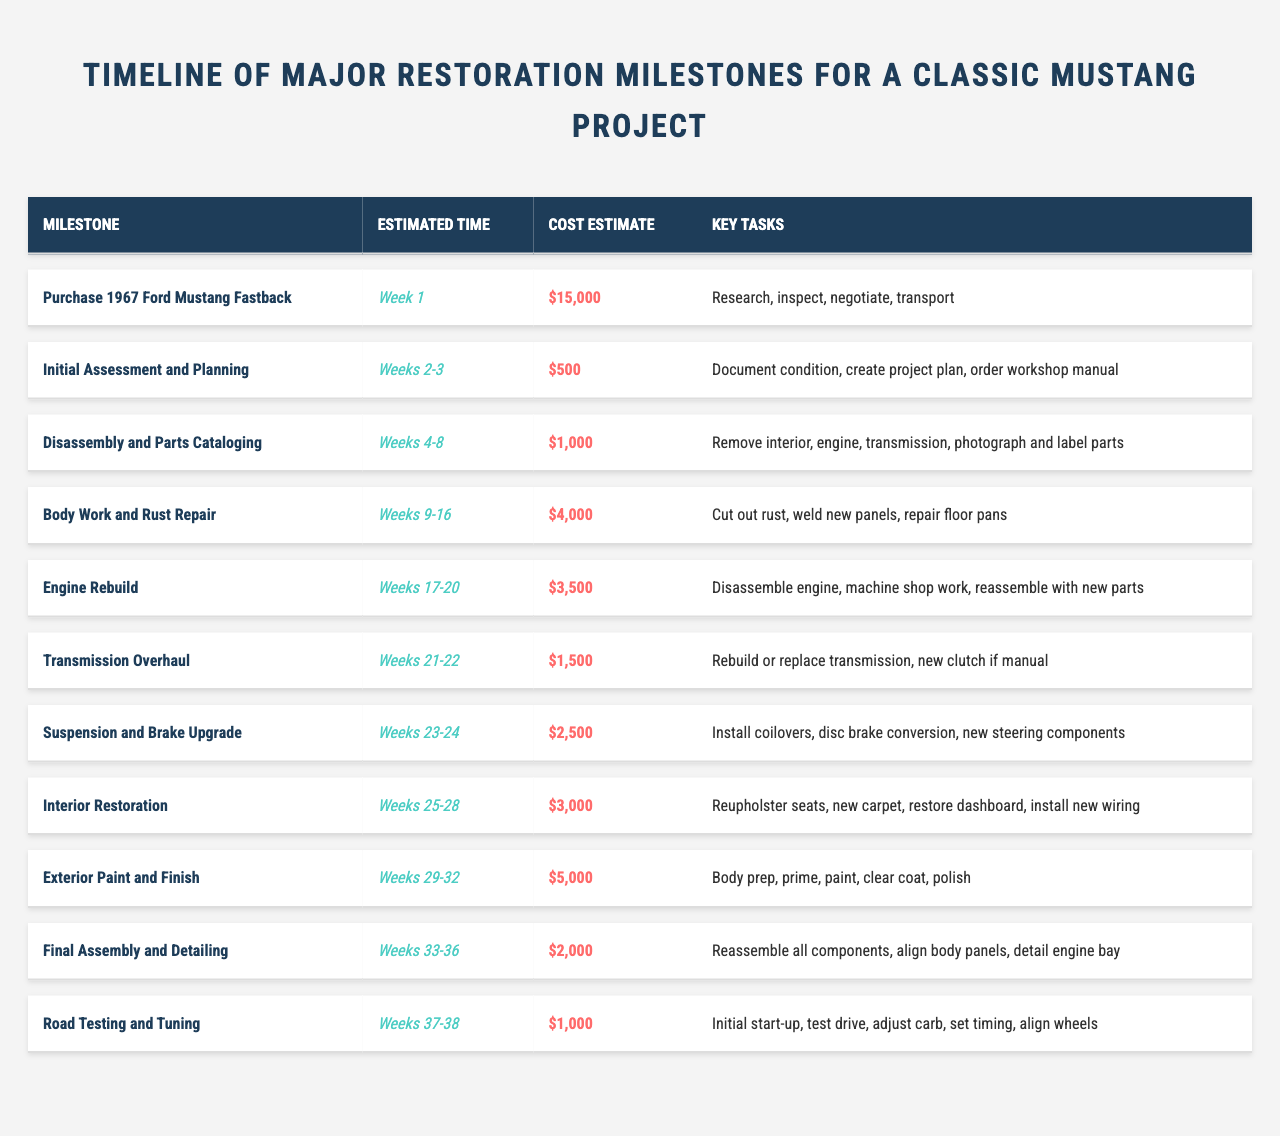What is the cost estimate for the engine rebuild milestone? The engine rebuild milestone in the table has a cost estimate listed as $3,500.
Answer: $3,500 How many weeks are estimated for the interior restoration? The interior restoration milestone is estimated to take 4 weeks, as it is listed under "Weeks 25-28."
Answer: 4 weeks What is the total estimated cost for the body work and rust repair and the exterior paint and finish? The body work and rust repair costs $4,000, while the exterior paint and finish costs $5,000. Adding them together gives $4,000 + $5,000 = $9,000.
Answer: $9,000 Is the initial assessment and planning milestone estimated to take more time than the suspension and brake upgrade? The initial assessment and planning takes weeks 2-3 (2 weeks), while the suspension and brake upgrade takes weeks 23-24 (2 weeks). Both have the same duration of 2 weeks, so the statement is false.
Answer: No Which milestone has the highest estimated cost, and what is that cost? By examining the cost estimates, the highest one is for the exterior paint and finish at $5,000.
Answer: Exterior paint and finish; $5,000 What are the total estimated costs for all milestones combined? To find the total, add up all cost estimates: $15,000 + $500 + $1,000 + $4,000 + $3,500 + $1,500 + $2,500 + $3,000 + $5,000 + $2,000 + $1,000 = $34,000.
Answer: $34,000 How many milestones are estimated to take longer than 2 weeks? The milestones taking longer than 2 weeks include disassembly and parts cataloging (5 weeks), body work and rust repair (8 weeks), engine rebuild (4 weeks), interior restoration (4 weeks), exterior paint and finish (4 weeks), final assembly and detailing (4 weeks), and road testing and tuning (2 weeks). That's 7 milestones.
Answer: 7 milestones What are the key tasks involved in the transmission overhaul? For the transmission overhaul, the key tasks are to rebuild or replace the transmission and to install a new clutch if manual.
Answer: Rebuild or replace transmission; new clutch if manual Which milestone occurs immediately after the engine rebuild? The milestone that follows the engine rebuild is the transmission overhaul, which starts in weeks 21-22 immediately after the engine rebuild weeks 17-20.
Answer: Transmission overhaul What is the estimated time frame for the final assembly and detailing? The final assembly and detailing milestone is scheduled for weeks 33-36, so it has a time frame of 4 weeks.
Answer: 4 weeks Which two milestones have the same estimated cost of $1,000? The two milestones with an estimated cost of $1,000 are disassembly and parts cataloging and road testing and tuning.
Answer: Disassembly and parts cataloging, road testing and tuning 